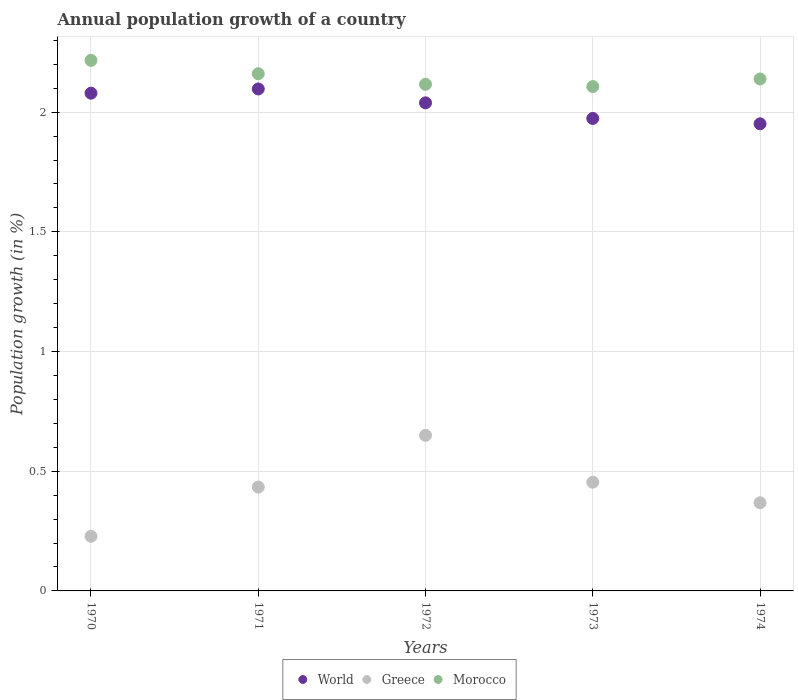Is the number of dotlines equal to the number of legend labels?
Provide a short and direct response. Yes. What is the annual population growth in World in 1972?
Offer a very short reply. 2.04. Across all years, what is the maximum annual population growth in World?
Give a very brief answer. 2.1. Across all years, what is the minimum annual population growth in Greece?
Offer a very short reply. 0.23. In which year was the annual population growth in Morocco minimum?
Provide a short and direct response. 1973. What is the total annual population growth in Greece in the graph?
Your answer should be very brief. 2.13. What is the difference between the annual population growth in Greece in 1970 and that in 1972?
Make the answer very short. -0.42. What is the difference between the annual population growth in Greece in 1973 and the annual population growth in Morocco in 1970?
Keep it short and to the point. -1.76. What is the average annual population growth in Morocco per year?
Provide a succinct answer. 2.15. In the year 1971, what is the difference between the annual population growth in World and annual population growth in Greece?
Your answer should be very brief. 1.66. In how many years, is the annual population growth in World greater than 1.2 %?
Your answer should be compact. 5. What is the ratio of the annual population growth in Greece in 1970 to that in 1972?
Make the answer very short. 0.35. Is the annual population growth in Greece in 1972 less than that in 1974?
Your response must be concise. No. Is the difference between the annual population growth in World in 1970 and 1971 greater than the difference between the annual population growth in Greece in 1970 and 1971?
Your answer should be very brief. Yes. What is the difference between the highest and the second highest annual population growth in Morocco?
Make the answer very short. 0.06. What is the difference between the highest and the lowest annual population growth in World?
Offer a very short reply. 0.15. In how many years, is the annual population growth in Morocco greater than the average annual population growth in Morocco taken over all years?
Keep it short and to the point. 2. Is the sum of the annual population growth in Morocco in 1971 and 1973 greater than the maximum annual population growth in World across all years?
Offer a very short reply. Yes. Is it the case that in every year, the sum of the annual population growth in Greece and annual population growth in World  is greater than the annual population growth in Morocco?
Offer a very short reply. Yes. Does the annual population growth in World monotonically increase over the years?
Provide a short and direct response. No. How many dotlines are there?
Offer a terse response. 3. How many years are there in the graph?
Your answer should be compact. 5. Are the values on the major ticks of Y-axis written in scientific E-notation?
Offer a very short reply. No. How many legend labels are there?
Offer a terse response. 3. What is the title of the graph?
Offer a terse response. Annual population growth of a country. What is the label or title of the Y-axis?
Make the answer very short. Population growth (in %). What is the Population growth (in %) in World in 1970?
Keep it short and to the point. 2.08. What is the Population growth (in %) of Greece in 1970?
Provide a succinct answer. 0.23. What is the Population growth (in %) in Morocco in 1970?
Provide a succinct answer. 2.22. What is the Population growth (in %) of World in 1971?
Provide a short and direct response. 2.1. What is the Population growth (in %) in Greece in 1971?
Offer a very short reply. 0.43. What is the Population growth (in %) of Morocco in 1971?
Keep it short and to the point. 2.16. What is the Population growth (in %) of World in 1972?
Provide a short and direct response. 2.04. What is the Population growth (in %) of Greece in 1972?
Your response must be concise. 0.65. What is the Population growth (in %) in Morocco in 1972?
Your response must be concise. 2.12. What is the Population growth (in %) of World in 1973?
Your response must be concise. 1.97. What is the Population growth (in %) in Greece in 1973?
Keep it short and to the point. 0.45. What is the Population growth (in %) in Morocco in 1973?
Provide a short and direct response. 2.11. What is the Population growth (in %) of World in 1974?
Make the answer very short. 1.95. What is the Population growth (in %) in Greece in 1974?
Give a very brief answer. 0.37. What is the Population growth (in %) in Morocco in 1974?
Make the answer very short. 2.14. Across all years, what is the maximum Population growth (in %) in World?
Keep it short and to the point. 2.1. Across all years, what is the maximum Population growth (in %) of Greece?
Give a very brief answer. 0.65. Across all years, what is the maximum Population growth (in %) in Morocco?
Ensure brevity in your answer.  2.22. Across all years, what is the minimum Population growth (in %) of World?
Give a very brief answer. 1.95. Across all years, what is the minimum Population growth (in %) in Greece?
Keep it short and to the point. 0.23. Across all years, what is the minimum Population growth (in %) in Morocco?
Your answer should be very brief. 2.11. What is the total Population growth (in %) of World in the graph?
Your answer should be compact. 10.14. What is the total Population growth (in %) of Greece in the graph?
Make the answer very short. 2.13. What is the total Population growth (in %) of Morocco in the graph?
Offer a very short reply. 10.74. What is the difference between the Population growth (in %) in World in 1970 and that in 1971?
Give a very brief answer. -0.02. What is the difference between the Population growth (in %) in Greece in 1970 and that in 1971?
Ensure brevity in your answer.  -0.21. What is the difference between the Population growth (in %) in Morocco in 1970 and that in 1971?
Keep it short and to the point. 0.06. What is the difference between the Population growth (in %) in World in 1970 and that in 1972?
Offer a very short reply. 0.04. What is the difference between the Population growth (in %) in Greece in 1970 and that in 1972?
Offer a terse response. -0.42. What is the difference between the Population growth (in %) of Morocco in 1970 and that in 1972?
Offer a terse response. 0.1. What is the difference between the Population growth (in %) in World in 1970 and that in 1973?
Keep it short and to the point. 0.11. What is the difference between the Population growth (in %) in Greece in 1970 and that in 1973?
Give a very brief answer. -0.23. What is the difference between the Population growth (in %) in Morocco in 1970 and that in 1973?
Offer a very short reply. 0.11. What is the difference between the Population growth (in %) of World in 1970 and that in 1974?
Your response must be concise. 0.13. What is the difference between the Population growth (in %) in Greece in 1970 and that in 1974?
Offer a very short reply. -0.14. What is the difference between the Population growth (in %) in Morocco in 1970 and that in 1974?
Your answer should be very brief. 0.08. What is the difference between the Population growth (in %) in World in 1971 and that in 1972?
Offer a terse response. 0.06. What is the difference between the Population growth (in %) of Greece in 1971 and that in 1972?
Offer a very short reply. -0.22. What is the difference between the Population growth (in %) in Morocco in 1971 and that in 1972?
Provide a succinct answer. 0.04. What is the difference between the Population growth (in %) of World in 1971 and that in 1973?
Your response must be concise. 0.12. What is the difference between the Population growth (in %) in Greece in 1971 and that in 1973?
Your response must be concise. -0.02. What is the difference between the Population growth (in %) of Morocco in 1971 and that in 1973?
Provide a succinct answer. 0.05. What is the difference between the Population growth (in %) in World in 1971 and that in 1974?
Provide a short and direct response. 0.15. What is the difference between the Population growth (in %) in Greece in 1971 and that in 1974?
Offer a terse response. 0.07. What is the difference between the Population growth (in %) of Morocco in 1971 and that in 1974?
Offer a terse response. 0.02. What is the difference between the Population growth (in %) of World in 1972 and that in 1973?
Provide a succinct answer. 0.07. What is the difference between the Population growth (in %) of Greece in 1972 and that in 1973?
Offer a terse response. 0.2. What is the difference between the Population growth (in %) of Morocco in 1972 and that in 1973?
Provide a short and direct response. 0.01. What is the difference between the Population growth (in %) of World in 1972 and that in 1974?
Offer a very short reply. 0.09. What is the difference between the Population growth (in %) of Greece in 1972 and that in 1974?
Offer a terse response. 0.28. What is the difference between the Population growth (in %) in Morocco in 1972 and that in 1974?
Make the answer very short. -0.02. What is the difference between the Population growth (in %) in World in 1973 and that in 1974?
Your response must be concise. 0.02. What is the difference between the Population growth (in %) of Greece in 1973 and that in 1974?
Offer a terse response. 0.09. What is the difference between the Population growth (in %) in Morocco in 1973 and that in 1974?
Provide a succinct answer. -0.03. What is the difference between the Population growth (in %) of World in 1970 and the Population growth (in %) of Greece in 1971?
Provide a succinct answer. 1.65. What is the difference between the Population growth (in %) in World in 1970 and the Population growth (in %) in Morocco in 1971?
Make the answer very short. -0.08. What is the difference between the Population growth (in %) of Greece in 1970 and the Population growth (in %) of Morocco in 1971?
Your answer should be compact. -1.93. What is the difference between the Population growth (in %) in World in 1970 and the Population growth (in %) in Greece in 1972?
Your answer should be very brief. 1.43. What is the difference between the Population growth (in %) of World in 1970 and the Population growth (in %) of Morocco in 1972?
Your answer should be compact. -0.04. What is the difference between the Population growth (in %) in Greece in 1970 and the Population growth (in %) in Morocco in 1972?
Ensure brevity in your answer.  -1.89. What is the difference between the Population growth (in %) in World in 1970 and the Population growth (in %) in Greece in 1973?
Your answer should be very brief. 1.63. What is the difference between the Population growth (in %) in World in 1970 and the Population growth (in %) in Morocco in 1973?
Your answer should be very brief. -0.03. What is the difference between the Population growth (in %) in Greece in 1970 and the Population growth (in %) in Morocco in 1973?
Your answer should be very brief. -1.88. What is the difference between the Population growth (in %) of World in 1970 and the Population growth (in %) of Greece in 1974?
Offer a terse response. 1.71. What is the difference between the Population growth (in %) in World in 1970 and the Population growth (in %) in Morocco in 1974?
Your response must be concise. -0.06. What is the difference between the Population growth (in %) of Greece in 1970 and the Population growth (in %) of Morocco in 1974?
Your answer should be compact. -1.91. What is the difference between the Population growth (in %) in World in 1971 and the Population growth (in %) in Greece in 1972?
Offer a terse response. 1.45. What is the difference between the Population growth (in %) in World in 1971 and the Population growth (in %) in Morocco in 1972?
Keep it short and to the point. -0.02. What is the difference between the Population growth (in %) of Greece in 1971 and the Population growth (in %) of Morocco in 1972?
Give a very brief answer. -1.68. What is the difference between the Population growth (in %) of World in 1971 and the Population growth (in %) of Greece in 1973?
Offer a terse response. 1.64. What is the difference between the Population growth (in %) of World in 1971 and the Population growth (in %) of Morocco in 1973?
Offer a very short reply. -0.01. What is the difference between the Population growth (in %) of Greece in 1971 and the Population growth (in %) of Morocco in 1973?
Your answer should be very brief. -1.67. What is the difference between the Population growth (in %) of World in 1971 and the Population growth (in %) of Greece in 1974?
Give a very brief answer. 1.73. What is the difference between the Population growth (in %) in World in 1971 and the Population growth (in %) in Morocco in 1974?
Your answer should be very brief. -0.04. What is the difference between the Population growth (in %) of Greece in 1971 and the Population growth (in %) of Morocco in 1974?
Provide a short and direct response. -1.7. What is the difference between the Population growth (in %) of World in 1972 and the Population growth (in %) of Greece in 1973?
Ensure brevity in your answer.  1.58. What is the difference between the Population growth (in %) in World in 1972 and the Population growth (in %) in Morocco in 1973?
Provide a succinct answer. -0.07. What is the difference between the Population growth (in %) of Greece in 1972 and the Population growth (in %) of Morocco in 1973?
Make the answer very short. -1.46. What is the difference between the Population growth (in %) in World in 1972 and the Population growth (in %) in Greece in 1974?
Provide a short and direct response. 1.67. What is the difference between the Population growth (in %) in World in 1972 and the Population growth (in %) in Morocco in 1974?
Offer a very short reply. -0.1. What is the difference between the Population growth (in %) of Greece in 1972 and the Population growth (in %) of Morocco in 1974?
Your response must be concise. -1.49. What is the difference between the Population growth (in %) of World in 1973 and the Population growth (in %) of Greece in 1974?
Ensure brevity in your answer.  1.61. What is the difference between the Population growth (in %) of World in 1973 and the Population growth (in %) of Morocco in 1974?
Keep it short and to the point. -0.16. What is the difference between the Population growth (in %) of Greece in 1973 and the Population growth (in %) of Morocco in 1974?
Your response must be concise. -1.68. What is the average Population growth (in %) of World per year?
Offer a very short reply. 2.03. What is the average Population growth (in %) in Greece per year?
Keep it short and to the point. 0.43. What is the average Population growth (in %) in Morocco per year?
Your answer should be very brief. 2.15. In the year 1970, what is the difference between the Population growth (in %) in World and Population growth (in %) in Greece?
Offer a very short reply. 1.85. In the year 1970, what is the difference between the Population growth (in %) of World and Population growth (in %) of Morocco?
Ensure brevity in your answer.  -0.14. In the year 1970, what is the difference between the Population growth (in %) in Greece and Population growth (in %) in Morocco?
Offer a very short reply. -1.99. In the year 1971, what is the difference between the Population growth (in %) of World and Population growth (in %) of Greece?
Provide a short and direct response. 1.66. In the year 1971, what is the difference between the Population growth (in %) of World and Population growth (in %) of Morocco?
Your answer should be very brief. -0.06. In the year 1971, what is the difference between the Population growth (in %) in Greece and Population growth (in %) in Morocco?
Your answer should be compact. -1.73. In the year 1972, what is the difference between the Population growth (in %) in World and Population growth (in %) in Greece?
Your answer should be compact. 1.39. In the year 1972, what is the difference between the Population growth (in %) in World and Population growth (in %) in Morocco?
Provide a short and direct response. -0.08. In the year 1972, what is the difference between the Population growth (in %) in Greece and Population growth (in %) in Morocco?
Provide a succinct answer. -1.47. In the year 1973, what is the difference between the Population growth (in %) of World and Population growth (in %) of Greece?
Offer a terse response. 1.52. In the year 1973, what is the difference between the Population growth (in %) in World and Population growth (in %) in Morocco?
Your answer should be compact. -0.13. In the year 1973, what is the difference between the Population growth (in %) in Greece and Population growth (in %) in Morocco?
Ensure brevity in your answer.  -1.65. In the year 1974, what is the difference between the Population growth (in %) in World and Population growth (in %) in Greece?
Provide a succinct answer. 1.58. In the year 1974, what is the difference between the Population growth (in %) of World and Population growth (in %) of Morocco?
Provide a succinct answer. -0.19. In the year 1974, what is the difference between the Population growth (in %) of Greece and Population growth (in %) of Morocco?
Keep it short and to the point. -1.77. What is the ratio of the Population growth (in %) of World in 1970 to that in 1971?
Your answer should be compact. 0.99. What is the ratio of the Population growth (in %) in Greece in 1970 to that in 1971?
Offer a terse response. 0.53. What is the ratio of the Population growth (in %) in Morocco in 1970 to that in 1971?
Keep it short and to the point. 1.03. What is the ratio of the Population growth (in %) in World in 1970 to that in 1972?
Offer a terse response. 1.02. What is the ratio of the Population growth (in %) in Greece in 1970 to that in 1972?
Offer a terse response. 0.35. What is the ratio of the Population growth (in %) of Morocco in 1970 to that in 1972?
Your answer should be very brief. 1.05. What is the ratio of the Population growth (in %) of World in 1970 to that in 1973?
Your answer should be compact. 1.05. What is the ratio of the Population growth (in %) in Greece in 1970 to that in 1973?
Provide a short and direct response. 0.5. What is the ratio of the Population growth (in %) in Morocco in 1970 to that in 1973?
Ensure brevity in your answer.  1.05. What is the ratio of the Population growth (in %) in World in 1970 to that in 1974?
Make the answer very short. 1.07. What is the ratio of the Population growth (in %) in Greece in 1970 to that in 1974?
Make the answer very short. 0.62. What is the ratio of the Population growth (in %) in Morocco in 1970 to that in 1974?
Ensure brevity in your answer.  1.04. What is the ratio of the Population growth (in %) in World in 1971 to that in 1972?
Ensure brevity in your answer.  1.03. What is the ratio of the Population growth (in %) of Greece in 1971 to that in 1972?
Your response must be concise. 0.67. What is the ratio of the Population growth (in %) of Morocco in 1971 to that in 1972?
Give a very brief answer. 1.02. What is the ratio of the Population growth (in %) in World in 1971 to that in 1973?
Provide a short and direct response. 1.06. What is the ratio of the Population growth (in %) in Greece in 1971 to that in 1973?
Provide a succinct answer. 0.96. What is the ratio of the Population growth (in %) in Morocco in 1971 to that in 1973?
Your answer should be compact. 1.03. What is the ratio of the Population growth (in %) in World in 1971 to that in 1974?
Offer a very short reply. 1.07. What is the ratio of the Population growth (in %) of Greece in 1971 to that in 1974?
Give a very brief answer. 1.18. What is the ratio of the Population growth (in %) of Morocco in 1971 to that in 1974?
Make the answer very short. 1.01. What is the ratio of the Population growth (in %) of World in 1972 to that in 1973?
Your answer should be very brief. 1.03. What is the ratio of the Population growth (in %) in Greece in 1972 to that in 1973?
Keep it short and to the point. 1.43. What is the ratio of the Population growth (in %) of Morocco in 1972 to that in 1973?
Give a very brief answer. 1. What is the ratio of the Population growth (in %) in World in 1972 to that in 1974?
Provide a short and direct response. 1.04. What is the ratio of the Population growth (in %) of Greece in 1972 to that in 1974?
Your answer should be very brief. 1.77. What is the ratio of the Population growth (in %) in World in 1973 to that in 1974?
Ensure brevity in your answer.  1.01. What is the ratio of the Population growth (in %) in Greece in 1973 to that in 1974?
Provide a succinct answer. 1.23. What is the ratio of the Population growth (in %) in Morocco in 1973 to that in 1974?
Keep it short and to the point. 0.99. What is the difference between the highest and the second highest Population growth (in %) in World?
Your answer should be compact. 0.02. What is the difference between the highest and the second highest Population growth (in %) of Greece?
Keep it short and to the point. 0.2. What is the difference between the highest and the second highest Population growth (in %) of Morocco?
Provide a succinct answer. 0.06. What is the difference between the highest and the lowest Population growth (in %) in World?
Your response must be concise. 0.15. What is the difference between the highest and the lowest Population growth (in %) in Greece?
Keep it short and to the point. 0.42. What is the difference between the highest and the lowest Population growth (in %) in Morocco?
Ensure brevity in your answer.  0.11. 